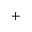<formula> <loc_0><loc_0><loc_500><loc_500>+</formula> 